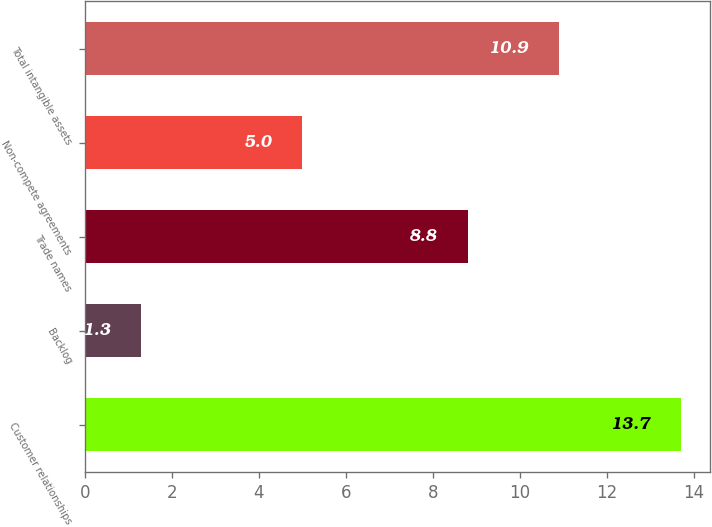Convert chart to OTSL. <chart><loc_0><loc_0><loc_500><loc_500><bar_chart><fcel>Customer relationships<fcel>Backlog<fcel>Trade names<fcel>Non-compete agreements<fcel>Total intangible assets<nl><fcel>13.7<fcel>1.3<fcel>8.8<fcel>5<fcel>10.9<nl></chart> 